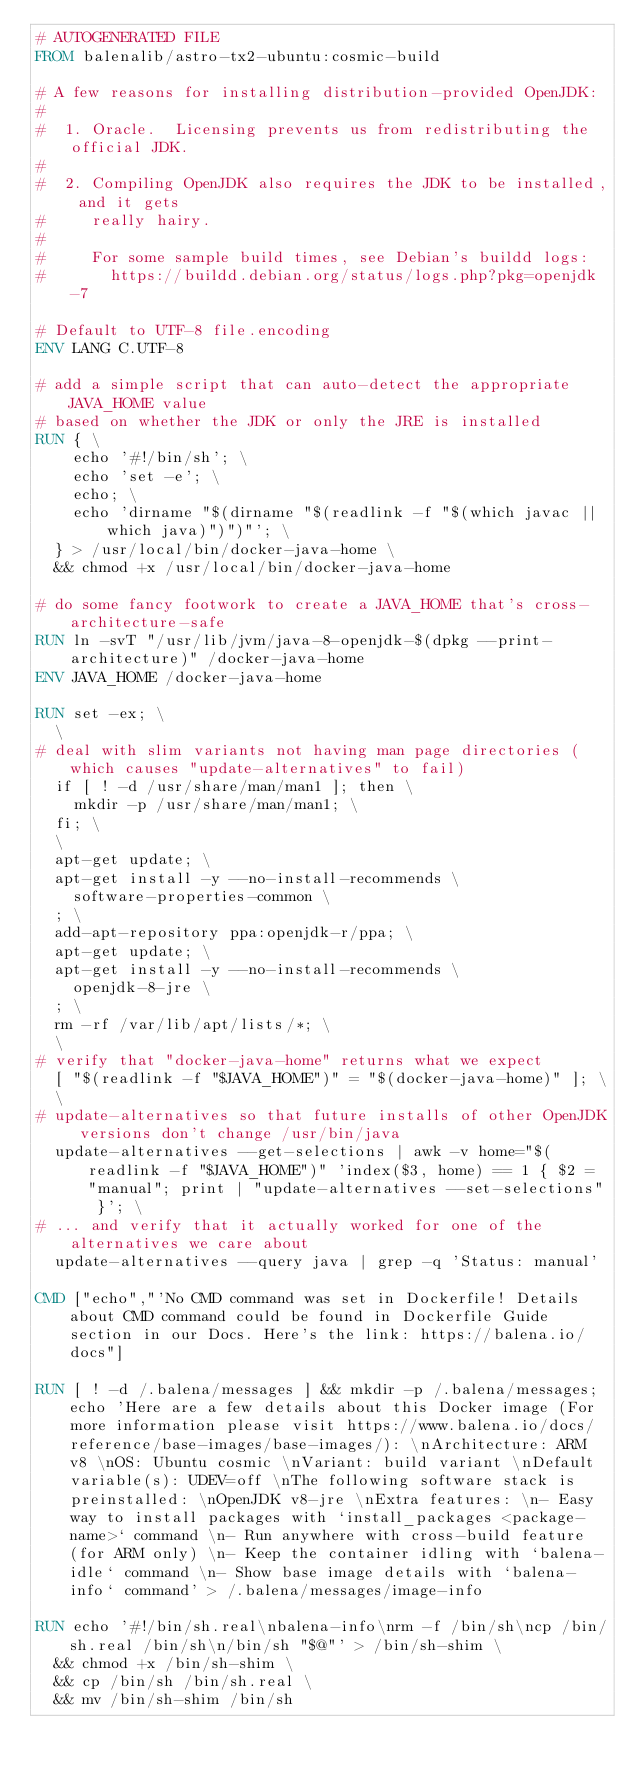<code> <loc_0><loc_0><loc_500><loc_500><_Dockerfile_># AUTOGENERATED FILE
FROM balenalib/astro-tx2-ubuntu:cosmic-build

# A few reasons for installing distribution-provided OpenJDK:
#
#  1. Oracle.  Licensing prevents us from redistributing the official JDK.
#
#  2. Compiling OpenJDK also requires the JDK to be installed, and it gets
#     really hairy.
#
#     For some sample build times, see Debian's buildd logs:
#       https://buildd.debian.org/status/logs.php?pkg=openjdk-7

# Default to UTF-8 file.encoding
ENV LANG C.UTF-8

# add a simple script that can auto-detect the appropriate JAVA_HOME value
# based on whether the JDK or only the JRE is installed
RUN { \
		echo '#!/bin/sh'; \
		echo 'set -e'; \
		echo; \
		echo 'dirname "$(dirname "$(readlink -f "$(which javac || which java)")")"'; \
	} > /usr/local/bin/docker-java-home \
	&& chmod +x /usr/local/bin/docker-java-home

# do some fancy footwork to create a JAVA_HOME that's cross-architecture-safe
RUN ln -svT "/usr/lib/jvm/java-8-openjdk-$(dpkg --print-architecture)" /docker-java-home
ENV JAVA_HOME /docker-java-home

RUN set -ex; \
	\
# deal with slim variants not having man page directories (which causes "update-alternatives" to fail)
	if [ ! -d /usr/share/man/man1 ]; then \
		mkdir -p /usr/share/man/man1; \
	fi; \
	\
	apt-get update; \
	apt-get install -y --no-install-recommends \
		software-properties-common \
	; \
	add-apt-repository ppa:openjdk-r/ppa; \
	apt-get update; \
	apt-get install -y --no-install-recommends \
		openjdk-8-jre \
	; \
	rm -rf /var/lib/apt/lists/*; \
	\
# verify that "docker-java-home" returns what we expect
	[ "$(readlink -f "$JAVA_HOME")" = "$(docker-java-home)" ]; \
	\
# update-alternatives so that future installs of other OpenJDK versions don't change /usr/bin/java
	update-alternatives --get-selections | awk -v home="$(readlink -f "$JAVA_HOME")" 'index($3, home) == 1 { $2 = "manual"; print | "update-alternatives --set-selections" }'; \
# ... and verify that it actually worked for one of the alternatives we care about
	update-alternatives --query java | grep -q 'Status: manual'

CMD ["echo","'No CMD command was set in Dockerfile! Details about CMD command could be found in Dockerfile Guide section in our Docs. Here's the link: https://balena.io/docs"]

RUN [ ! -d /.balena/messages ] && mkdir -p /.balena/messages; echo 'Here are a few details about this Docker image (For more information please visit https://www.balena.io/docs/reference/base-images/base-images/): \nArchitecture: ARM v8 \nOS: Ubuntu cosmic \nVariant: build variant \nDefault variable(s): UDEV=off \nThe following software stack is preinstalled: \nOpenJDK v8-jre \nExtra features: \n- Easy way to install packages with `install_packages <package-name>` command \n- Run anywhere with cross-build feature  (for ARM only) \n- Keep the container idling with `balena-idle` command \n- Show base image details with `balena-info` command' > /.balena/messages/image-info

RUN echo '#!/bin/sh.real\nbalena-info\nrm -f /bin/sh\ncp /bin/sh.real /bin/sh\n/bin/sh "$@"' > /bin/sh-shim \
	&& chmod +x /bin/sh-shim \
	&& cp /bin/sh /bin/sh.real \
	&& mv /bin/sh-shim /bin/sh</code> 